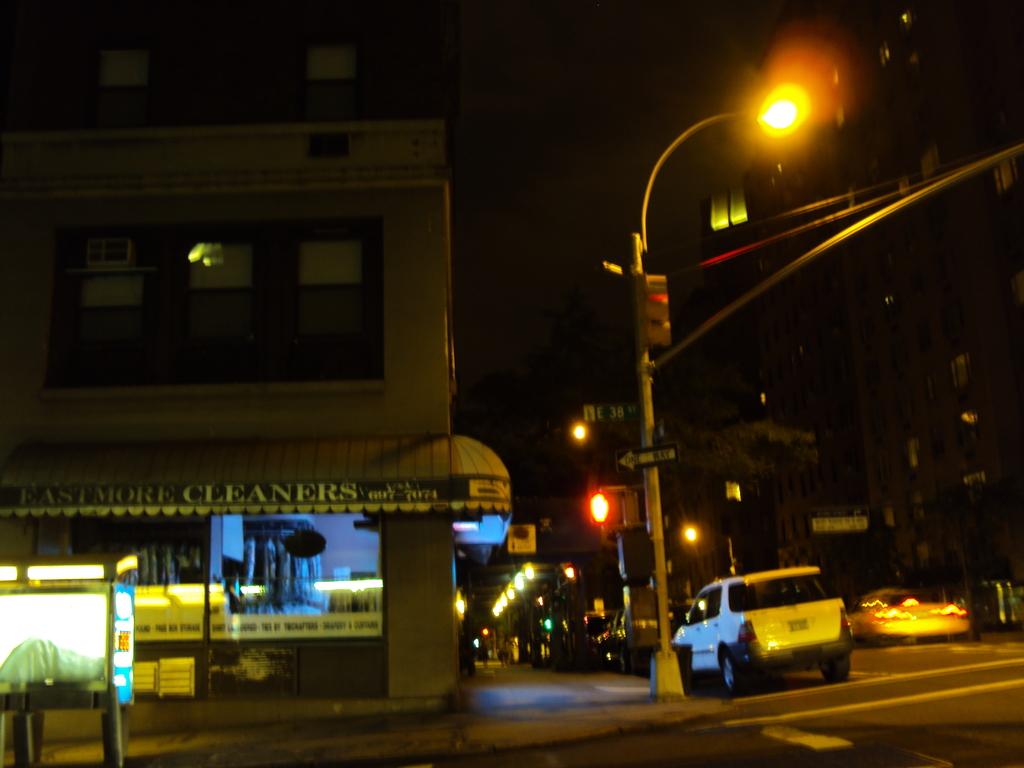What store is on the left?
Ensure brevity in your answer.  Eastmore cleaners. What does the black sign with the white arrow say?
Offer a very short reply. One way. 